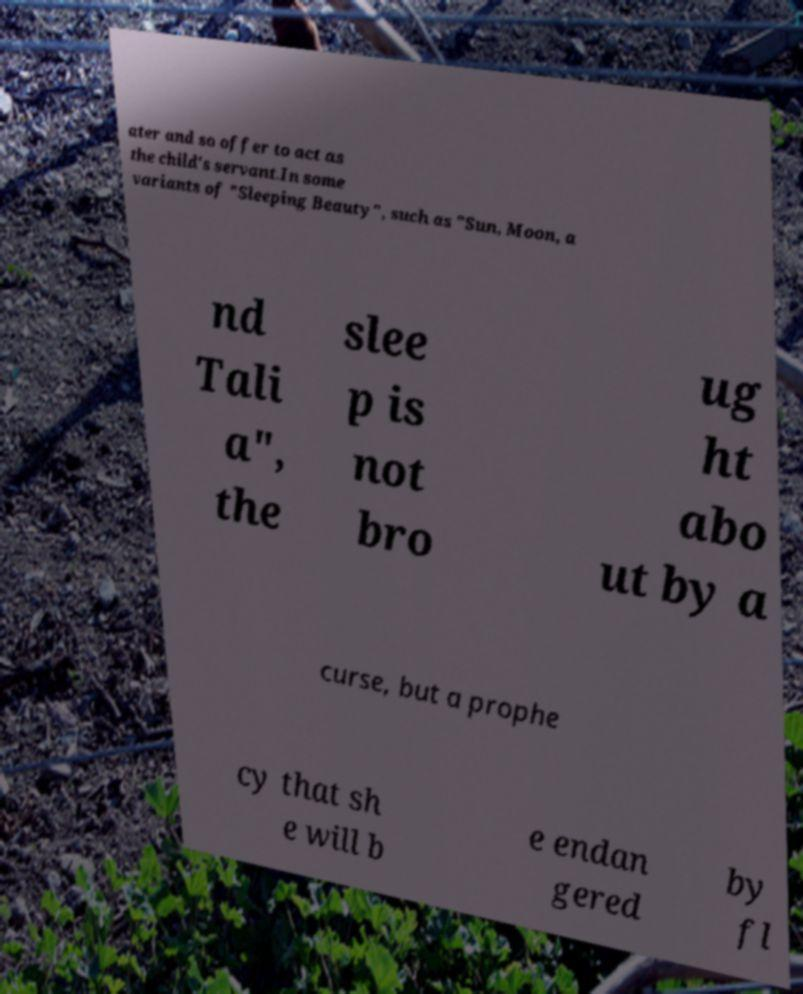Could you assist in decoding the text presented in this image and type it out clearly? ater and so offer to act as the child's servant.In some variants of "Sleeping Beauty", such as "Sun, Moon, a nd Tali a", the slee p is not bro ug ht abo ut by a curse, but a prophe cy that sh e will b e endan gered by fl 